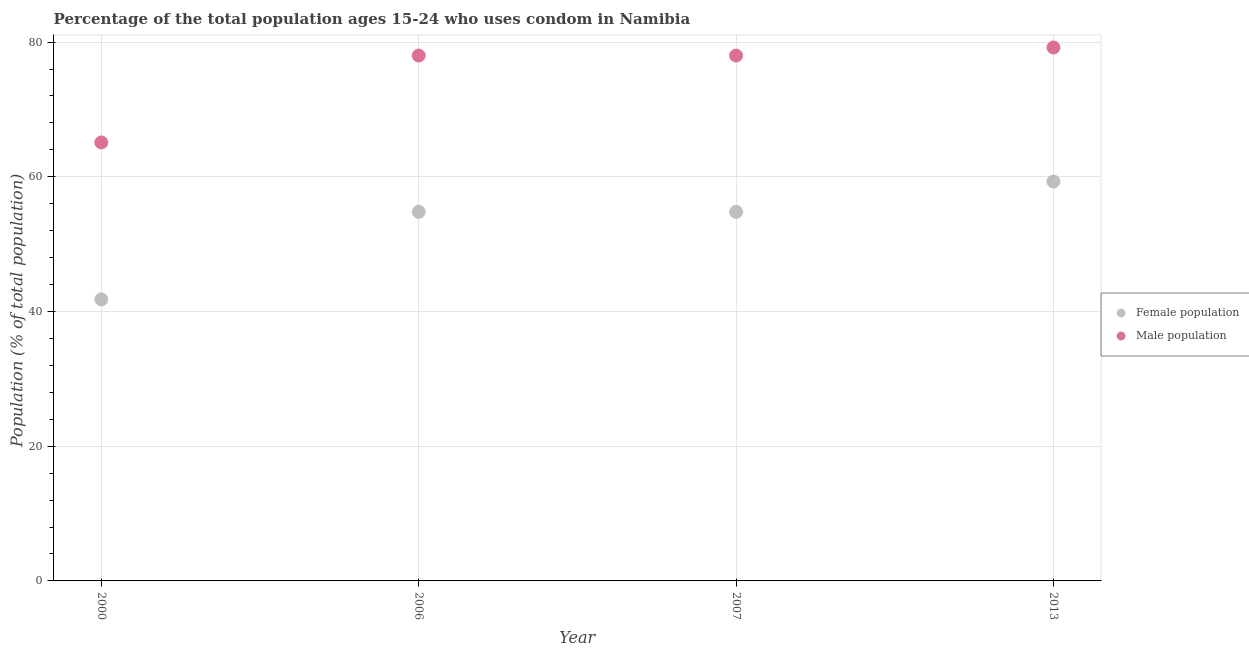How many different coloured dotlines are there?
Make the answer very short. 2. What is the male population in 2013?
Offer a terse response. 79.2. Across all years, what is the maximum female population?
Your response must be concise. 59.3. Across all years, what is the minimum male population?
Make the answer very short. 65.1. In which year was the female population maximum?
Your answer should be compact. 2013. In which year was the male population minimum?
Offer a terse response. 2000. What is the total female population in the graph?
Your answer should be compact. 210.7. What is the difference between the female population in 2000 and that in 2013?
Ensure brevity in your answer.  -17.5. What is the difference between the female population in 2007 and the male population in 2006?
Your response must be concise. -23.2. What is the average male population per year?
Your response must be concise. 75.08. In the year 2013, what is the difference between the female population and male population?
Your answer should be compact. -19.9. What is the ratio of the female population in 2006 to that in 2013?
Give a very brief answer. 0.92. Is the female population in 2000 less than that in 2006?
Provide a short and direct response. Yes. Is the difference between the male population in 2000 and 2006 greater than the difference between the female population in 2000 and 2006?
Offer a very short reply. Yes. In how many years, is the male population greater than the average male population taken over all years?
Offer a terse response. 3. Is the female population strictly greater than the male population over the years?
Provide a succinct answer. No. How many years are there in the graph?
Provide a succinct answer. 4. Does the graph contain grids?
Keep it short and to the point. Yes. Where does the legend appear in the graph?
Keep it short and to the point. Center right. How many legend labels are there?
Offer a very short reply. 2. How are the legend labels stacked?
Provide a short and direct response. Vertical. What is the title of the graph?
Ensure brevity in your answer.  Percentage of the total population ages 15-24 who uses condom in Namibia. What is the label or title of the Y-axis?
Keep it short and to the point. Population (% of total population) . What is the Population (% of total population)  in Female population in 2000?
Offer a very short reply. 41.8. What is the Population (% of total population)  in Male population in 2000?
Offer a terse response. 65.1. What is the Population (% of total population)  in Female population in 2006?
Give a very brief answer. 54.8. What is the Population (% of total population)  in Female population in 2007?
Provide a short and direct response. 54.8. What is the Population (% of total population)  in Male population in 2007?
Your response must be concise. 78. What is the Population (% of total population)  of Female population in 2013?
Ensure brevity in your answer.  59.3. What is the Population (% of total population)  in Male population in 2013?
Keep it short and to the point. 79.2. Across all years, what is the maximum Population (% of total population)  of Female population?
Keep it short and to the point. 59.3. Across all years, what is the maximum Population (% of total population)  of Male population?
Offer a terse response. 79.2. Across all years, what is the minimum Population (% of total population)  of Female population?
Provide a short and direct response. 41.8. Across all years, what is the minimum Population (% of total population)  in Male population?
Offer a very short reply. 65.1. What is the total Population (% of total population)  in Female population in the graph?
Provide a succinct answer. 210.7. What is the total Population (% of total population)  of Male population in the graph?
Offer a terse response. 300.3. What is the difference between the Population (% of total population)  of Female population in 2000 and that in 2006?
Give a very brief answer. -13. What is the difference between the Population (% of total population)  of Male population in 2000 and that in 2006?
Give a very brief answer. -12.9. What is the difference between the Population (% of total population)  in Female population in 2000 and that in 2013?
Provide a short and direct response. -17.5. What is the difference between the Population (% of total population)  of Male population in 2000 and that in 2013?
Give a very brief answer. -14.1. What is the difference between the Population (% of total population)  of Female population in 2006 and that in 2013?
Keep it short and to the point. -4.5. What is the difference between the Population (% of total population)  of Male population in 2006 and that in 2013?
Provide a short and direct response. -1.2. What is the difference between the Population (% of total population)  of Female population in 2000 and the Population (% of total population)  of Male population in 2006?
Provide a short and direct response. -36.2. What is the difference between the Population (% of total population)  of Female population in 2000 and the Population (% of total population)  of Male population in 2007?
Provide a short and direct response. -36.2. What is the difference between the Population (% of total population)  in Female population in 2000 and the Population (% of total population)  in Male population in 2013?
Your answer should be very brief. -37.4. What is the difference between the Population (% of total population)  in Female population in 2006 and the Population (% of total population)  in Male population in 2007?
Offer a terse response. -23.2. What is the difference between the Population (% of total population)  in Female population in 2006 and the Population (% of total population)  in Male population in 2013?
Give a very brief answer. -24.4. What is the difference between the Population (% of total population)  of Female population in 2007 and the Population (% of total population)  of Male population in 2013?
Your answer should be very brief. -24.4. What is the average Population (% of total population)  in Female population per year?
Your answer should be compact. 52.67. What is the average Population (% of total population)  of Male population per year?
Your answer should be very brief. 75.08. In the year 2000, what is the difference between the Population (% of total population)  of Female population and Population (% of total population)  of Male population?
Your response must be concise. -23.3. In the year 2006, what is the difference between the Population (% of total population)  of Female population and Population (% of total population)  of Male population?
Your answer should be compact. -23.2. In the year 2007, what is the difference between the Population (% of total population)  in Female population and Population (% of total population)  in Male population?
Keep it short and to the point. -23.2. In the year 2013, what is the difference between the Population (% of total population)  of Female population and Population (% of total population)  of Male population?
Give a very brief answer. -19.9. What is the ratio of the Population (% of total population)  in Female population in 2000 to that in 2006?
Provide a short and direct response. 0.76. What is the ratio of the Population (% of total population)  in Male population in 2000 to that in 2006?
Ensure brevity in your answer.  0.83. What is the ratio of the Population (% of total population)  in Female population in 2000 to that in 2007?
Your answer should be compact. 0.76. What is the ratio of the Population (% of total population)  in Male population in 2000 to that in 2007?
Keep it short and to the point. 0.83. What is the ratio of the Population (% of total population)  of Female population in 2000 to that in 2013?
Your response must be concise. 0.7. What is the ratio of the Population (% of total population)  of Male population in 2000 to that in 2013?
Make the answer very short. 0.82. What is the ratio of the Population (% of total population)  in Female population in 2006 to that in 2007?
Your answer should be compact. 1. What is the ratio of the Population (% of total population)  in Male population in 2006 to that in 2007?
Offer a very short reply. 1. What is the ratio of the Population (% of total population)  of Female population in 2006 to that in 2013?
Provide a succinct answer. 0.92. What is the ratio of the Population (% of total population)  in Male population in 2006 to that in 2013?
Keep it short and to the point. 0.98. What is the ratio of the Population (% of total population)  of Female population in 2007 to that in 2013?
Offer a very short reply. 0.92. What is the difference between the highest and the second highest Population (% of total population)  of Female population?
Provide a short and direct response. 4.5. What is the difference between the highest and the lowest Population (% of total population)  in Female population?
Provide a succinct answer. 17.5. What is the difference between the highest and the lowest Population (% of total population)  of Male population?
Provide a succinct answer. 14.1. 